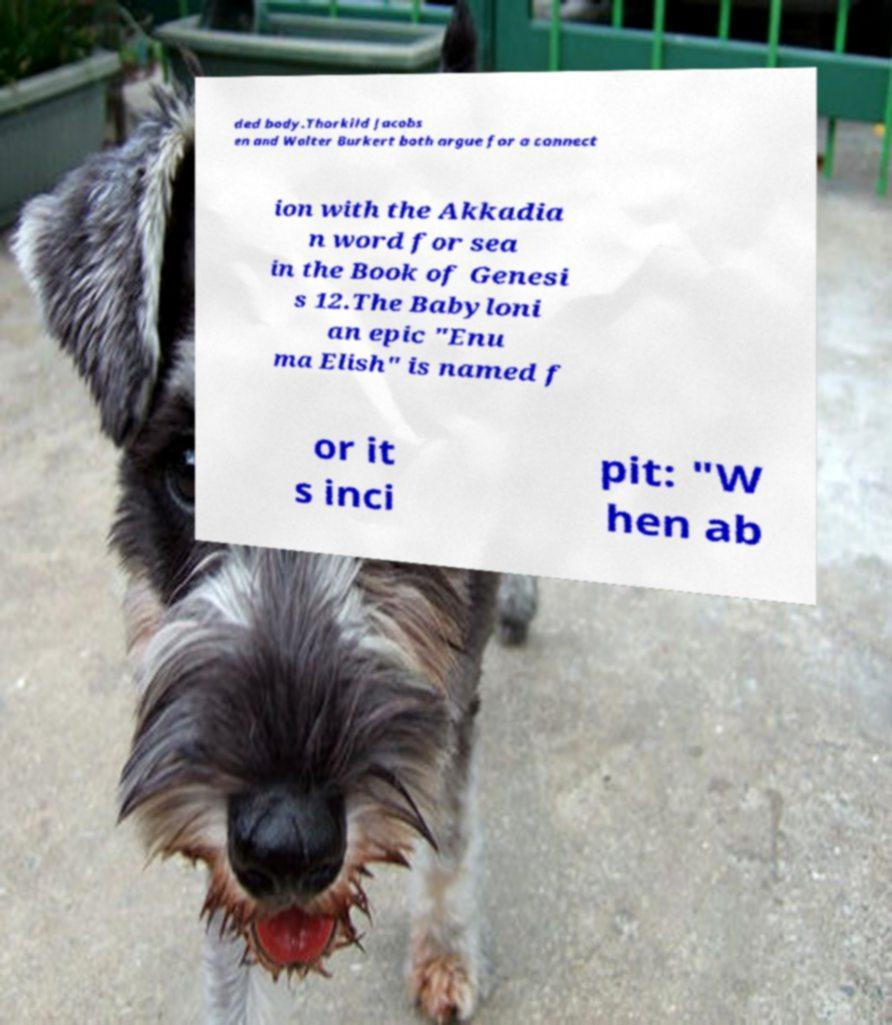For documentation purposes, I need the text within this image transcribed. Could you provide that? ded body.Thorkild Jacobs en and Walter Burkert both argue for a connect ion with the Akkadia n word for sea in the Book of Genesi s 12.The Babyloni an epic "Enu ma Elish" is named f or it s inci pit: "W hen ab 